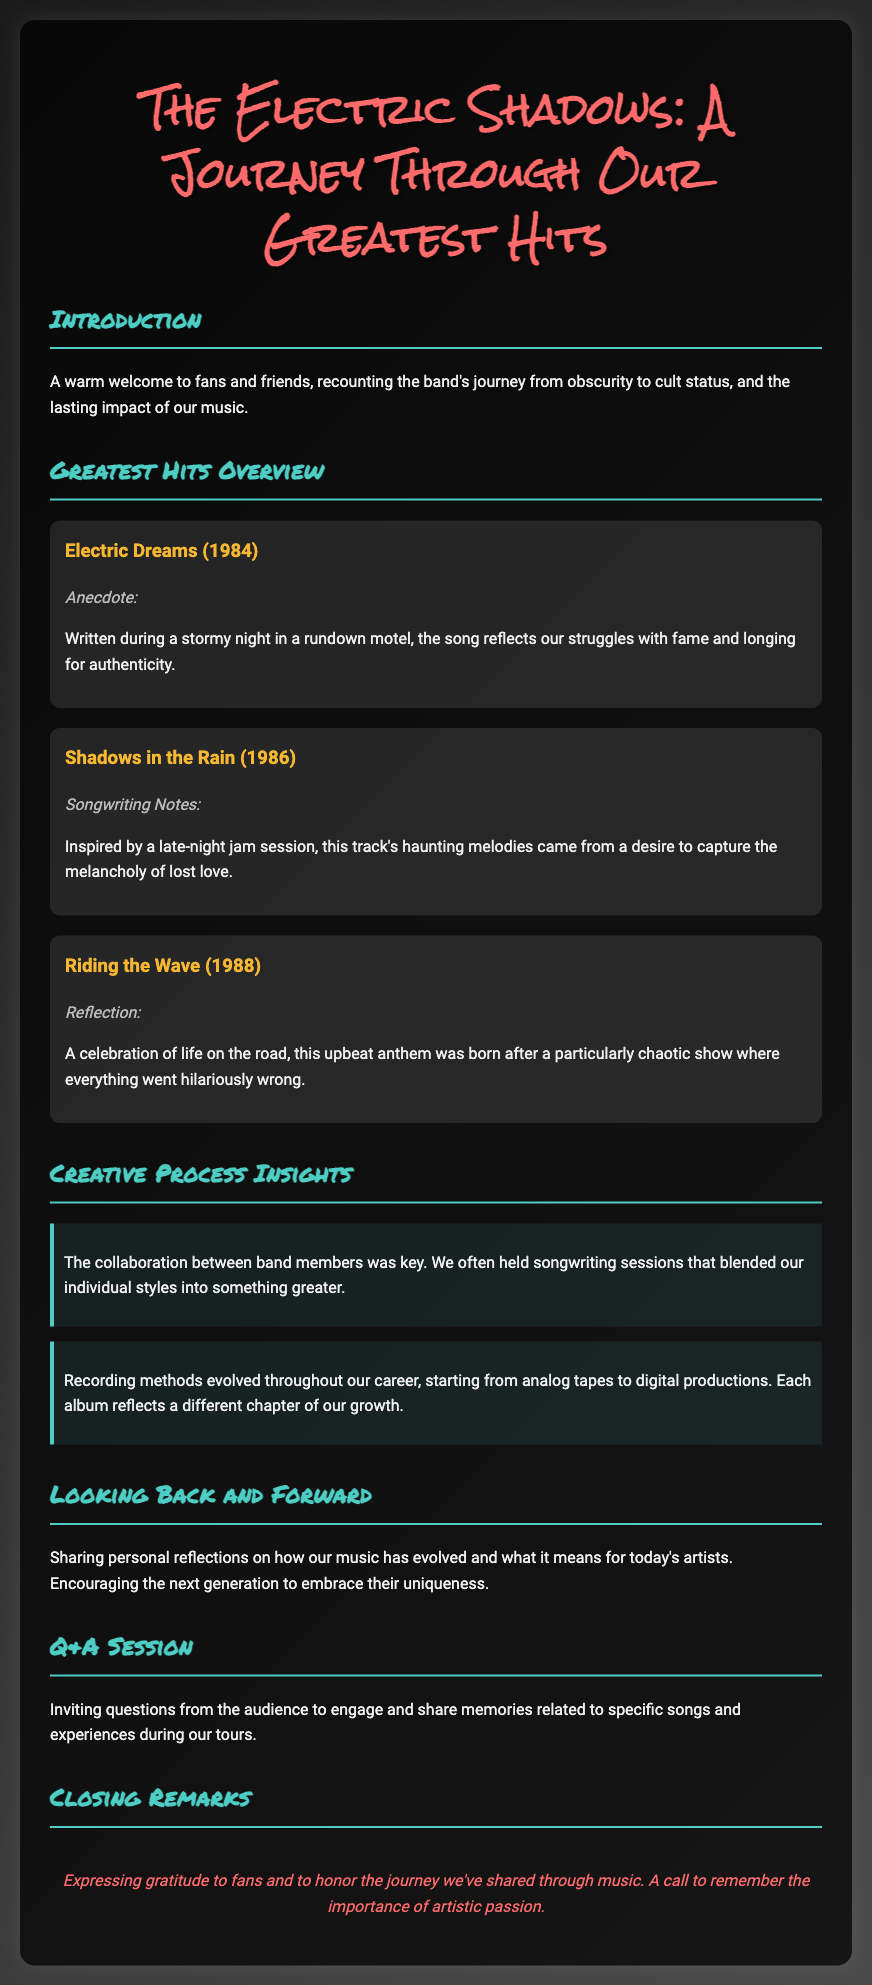What is the title of the retrospective? The title of the retrospective is mentioned at the top of the document.
Answer: The Electric Shadows: A Journey Through Our Greatest Hits In what year was "Electric Dreams" released? The document provides the release year for each song in the Greatest Hits Overview.
Answer: 1984 What inspired the song "Shadows in the Rain"? The document describes the inspiration for each song's writing in the Greatest Hits Overview.
Answer: A late-night jam session What was the main theme of "Riding the Wave"? The document summarizes the essence or message of each song in the Overview section.
Answer: Celebration of life on the road How did the band members collaborate during songwriting? The Creative Process Insights section provides information on how the band created songs together.
Answer: Blended individual styles What type of recording methods did the band start with? The Creative Process Insights discusses the evolution of the band's recording methods over time.
Answer: Analog tapes What is the purpose of the Q&A session? The document indicates the intent of the Q&A section, which is open to audience participation.
Answer: Engage and share memories What is expressed in the closing remarks? The closing remarks section concludes the document with gratitude and reflections.
Answer: Gratitude to fans 